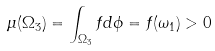<formula> <loc_0><loc_0><loc_500><loc_500>\mu ( \Omega _ { 3 } ) = \int _ { \Omega _ { 3 } } f d \phi = f ( \omega _ { 1 } ) > 0</formula> 